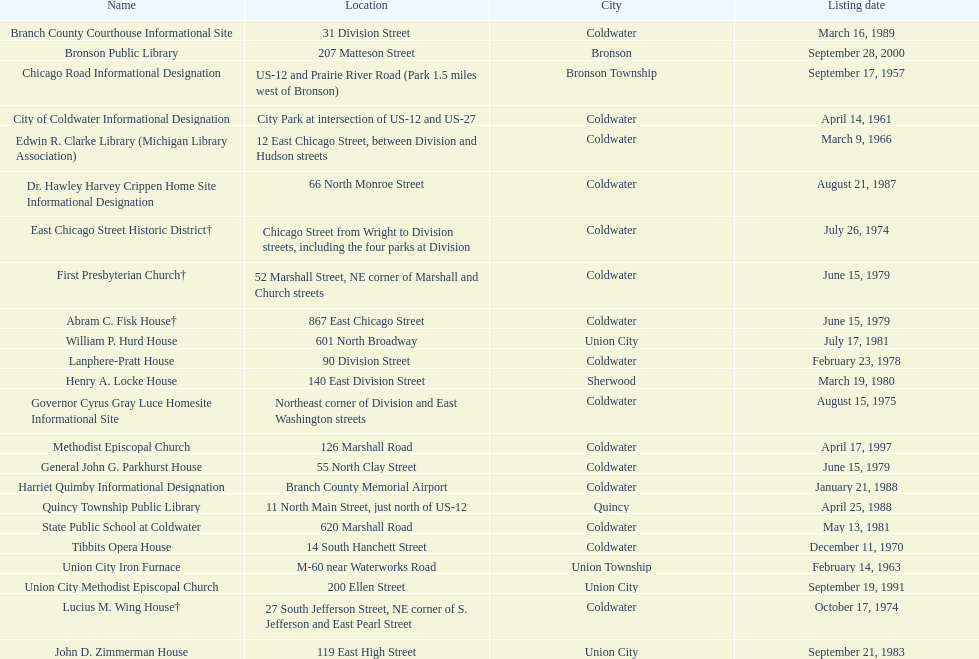What is the name for the exclusive listing date on april 14, 1961? City of Coldwater. 